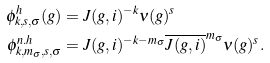<formula> <loc_0><loc_0><loc_500><loc_500>\phi ^ { h } _ { k , s , \sigma } ( g ) & = J ( g , i ) ^ { - k } \nu ( g ) ^ { s } \\ \phi ^ { n . h } _ { k , m _ { \sigma } , s , \sigma } & = J ( g , i ) ^ { - k - m _ { \sigma } } \overline { J ( g , i ) } ^ { m _ { \sigma } } \nu ( g ) ^ { s } .</formula> 